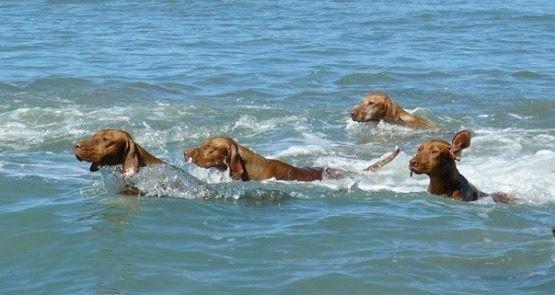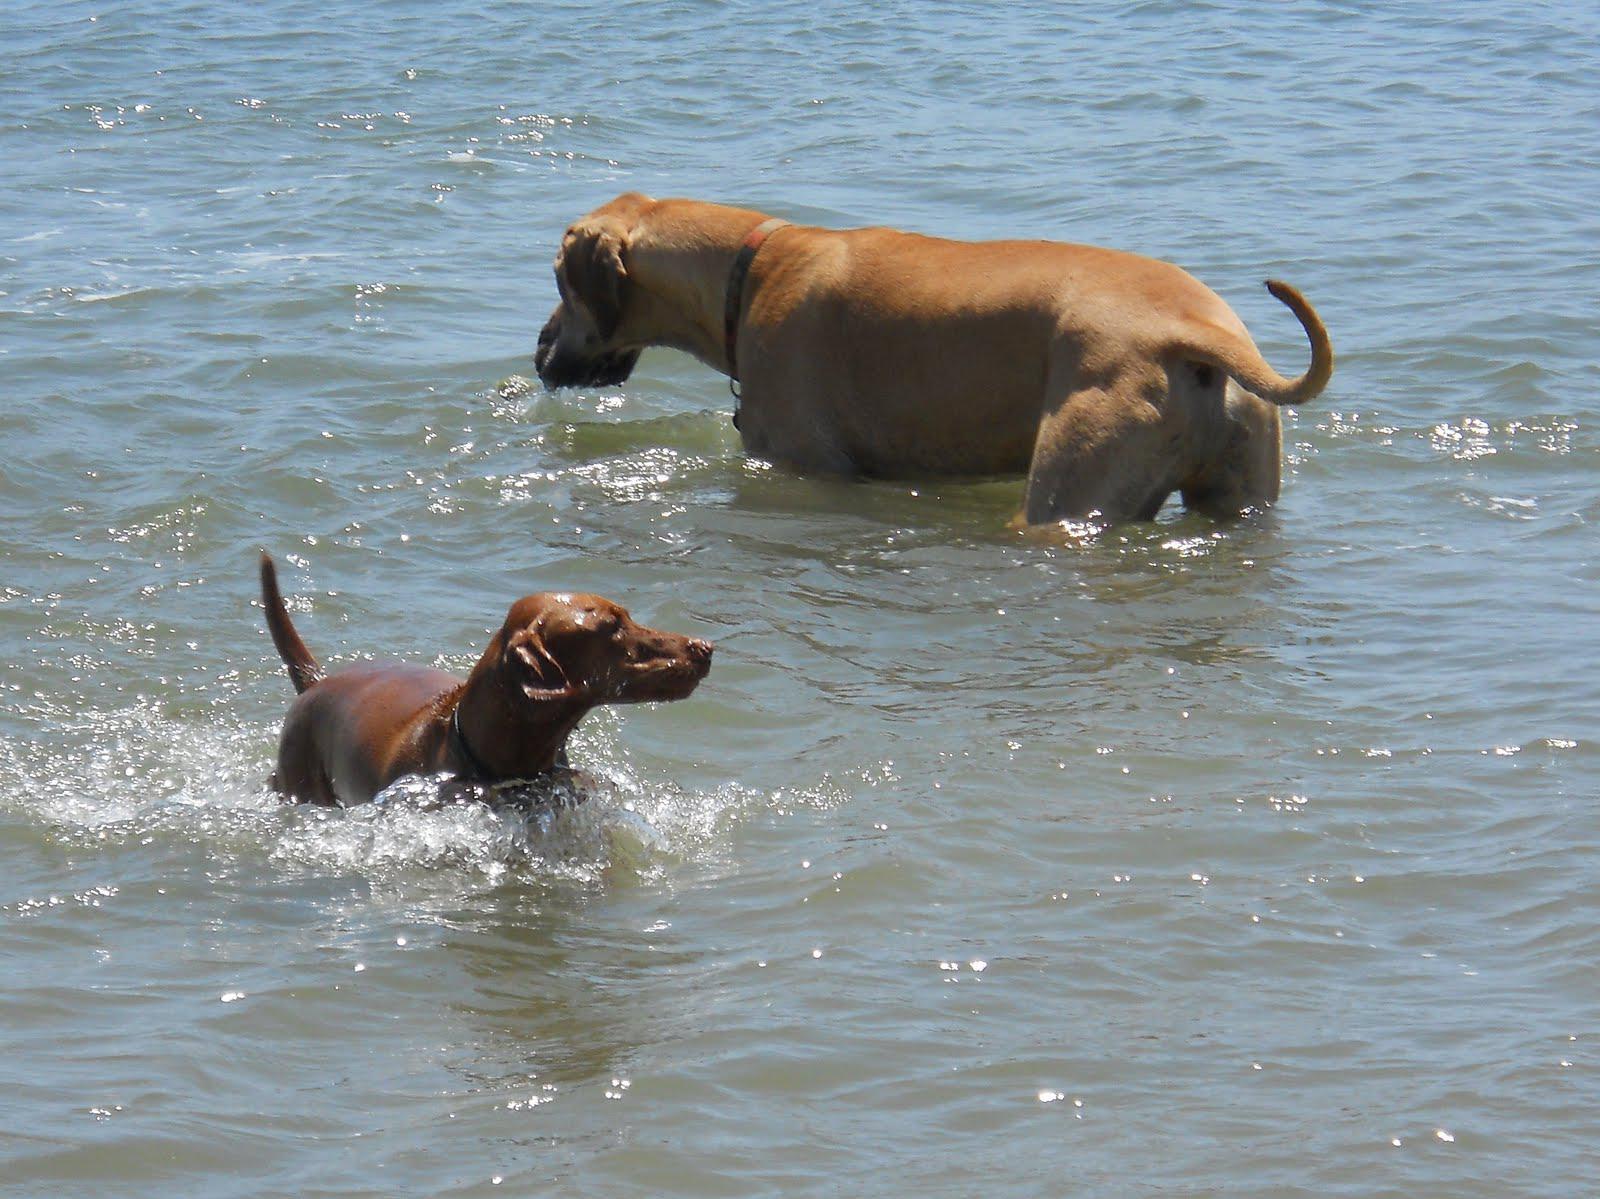The first image is the image on the left, the second image is the image on the right. Analyze the images presented: Is the assertion "There are three dogs in the image pair." valid? Answer yes or no. No. The first image is the image on the left, the second image is the image on the right. For the images displayed, is the sentence "The dog in the image on the right is standing on the sand." factually correct? Answer yes or no. No. 